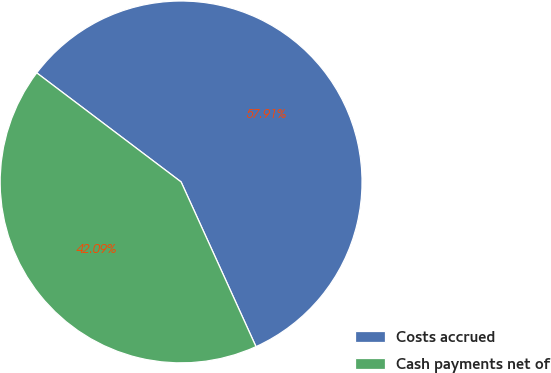Convert chart to OTSL. <chart><loc_0><loc_0><loc_500><loc_500><pie_chart><fcel>Costs accrued<fcel>Cash payments net of<nl><fcel>57.91%<fcel>42.09%<nl></chart> 